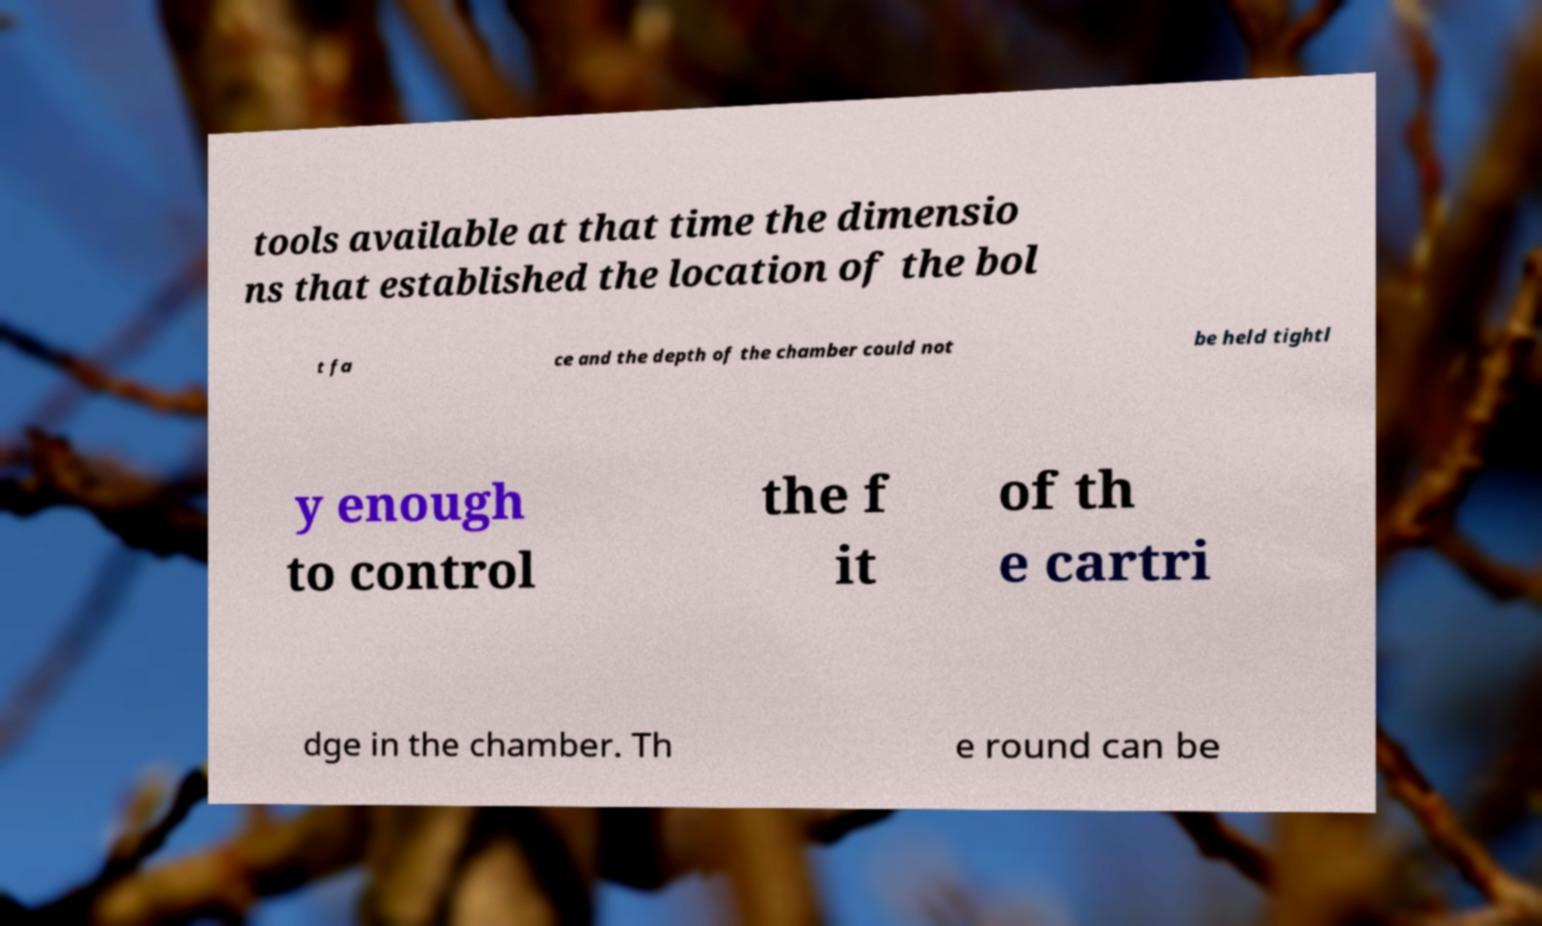Could you assist in decoding the text presented in this image and type it out clearly? tools available at that time the dimensio ns that established the location of the bol t fa ce and the depth of the chamber could not be held tightl y enough to control the f it of th e cartri dge in the chamber. Th e round can be 